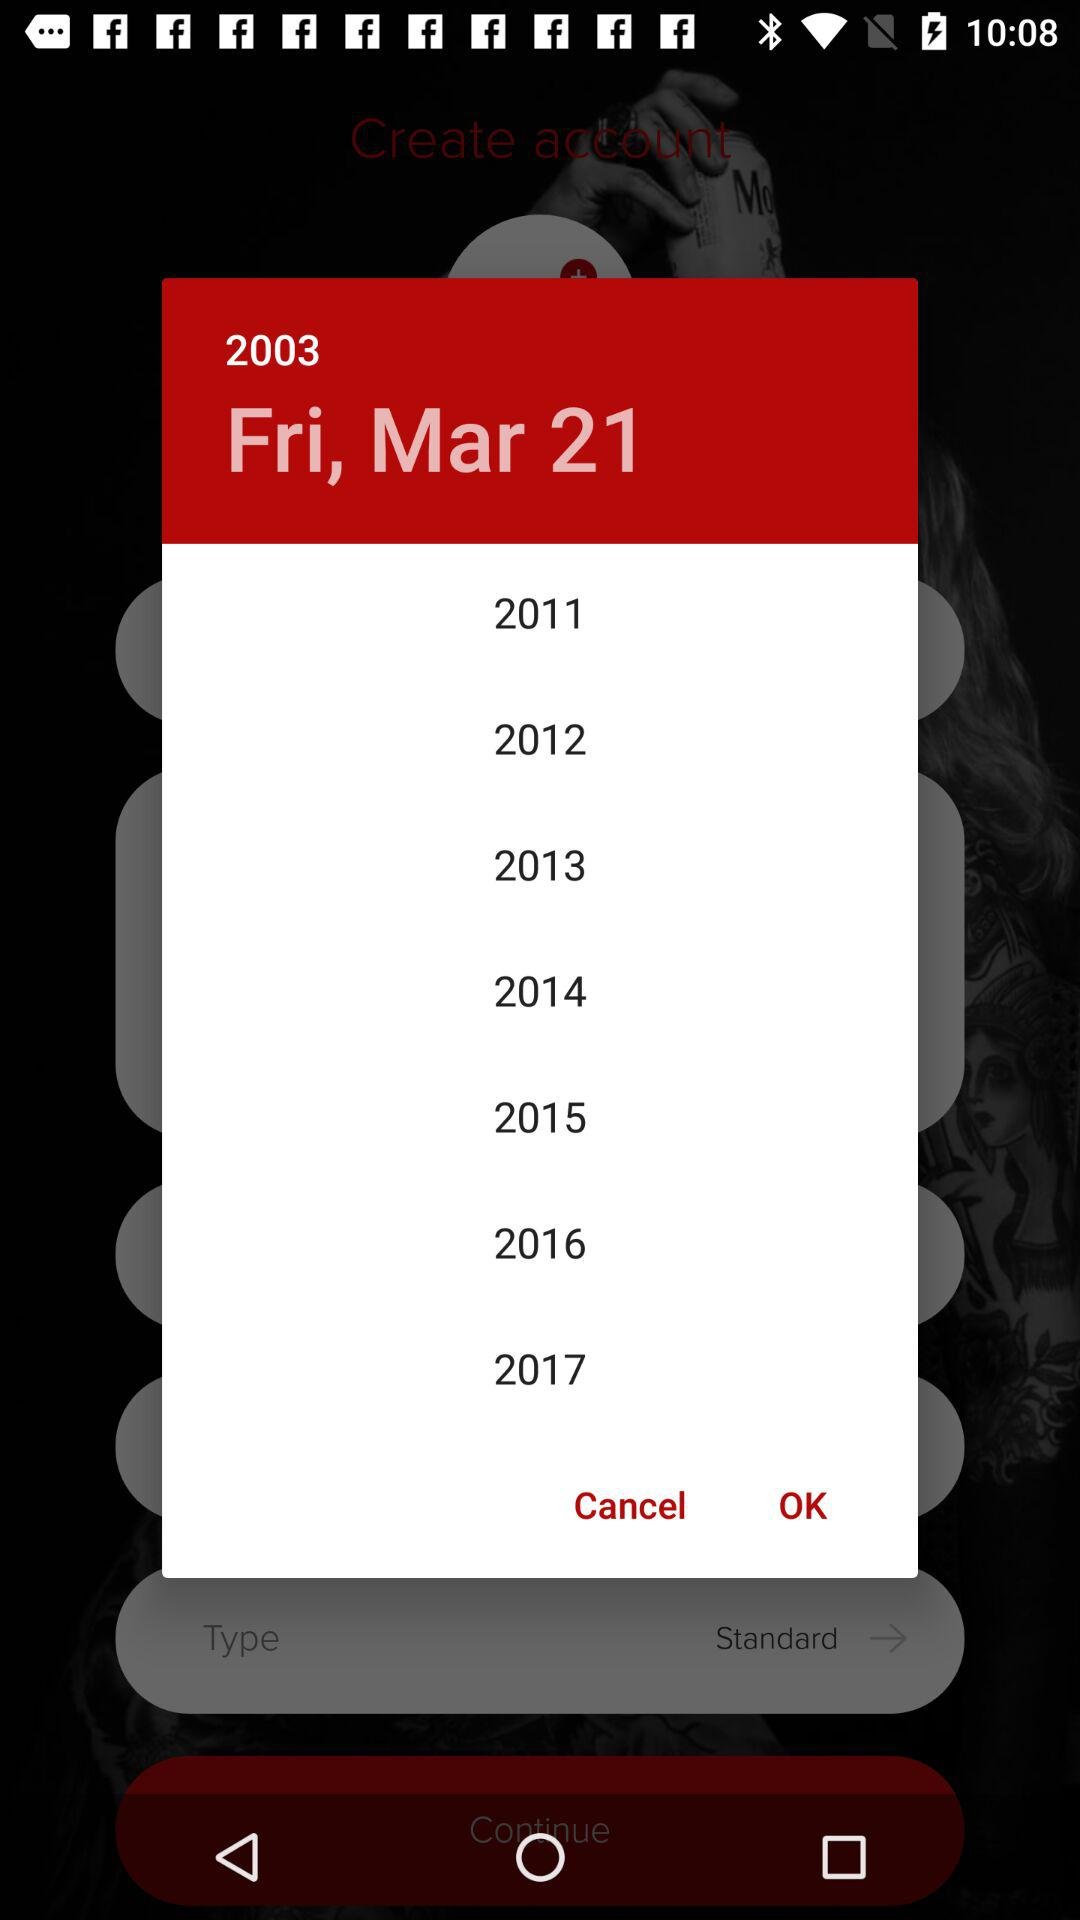What is the selected year? The selected year is 2003. 